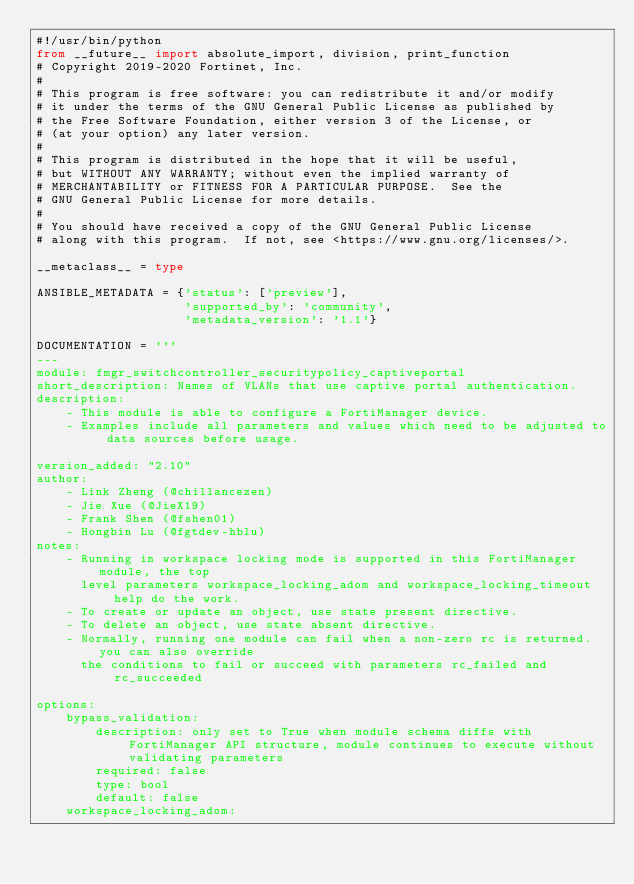Convert code to text. <code><loc_0><loc_0><loc_500><loc_500><_Python_>#!/usr/bin/python
from __future__ import absolute_import, division, print_function
# Copyright 2019-2020 Fortinet, Inc.
#
# This program is free software: you can redistribute it and/or modify
# it under the terms of the GNU General Public License as published by
# the Free Software Foundation, either version 3 of the License, or
# (at your option) any later version.
#
# This program is distributed in the hope that it will be useful,
# but WITHOUT ANY WARRANTY; without even the implied warranty of
# MERCHANTABILITY or FITNESS FOR A PARTICULAR PURPOSE.  See the
# GNU General Public License for more details.
#
# You should have received a copy of the GNU General Public License
# along with this program.  If not, see <https://www.gnu.org/licenses/>.

__metaclass__ = type

ANSIBLE_METADATA = {'status': ['preview'],
                    'supported_by': 'community',
                    'metadata_version': '1.1'}

DOCUMENTATION = '''
---
module: fmgr_switchcontroller_securitypolicy_captiveportal
short_description: Names of VLANs that use captive portal authentication.
description:
    - This module is able to configure a FortiManager device.
    - Examples include all parameters and values which need to be adjusted to data sources before usage.

version_added: "2.10"
author:
    - Link Zheng (@chillancezen)
    - Jie Xue (@JieX19)
    - Frank Shen (@fshen01)
    - Hongbin Lu (@fgtdev-hblu)
notes:
    - Running in workspace locking mode is supported in this FortiManager module, the top
      level parameters workspace_locking_adom and workspace_locking_timeout help do the work.
    - To create or update an object, use state present directive.
    - To delete an object, use state absent directive.
    - Normally, running one module can fail when a non-zero rc is returned. you can also override
      the conditions to fail or succeed with parameters rc_failed and rc_succeeded

options:
    bypass_validation:
        description: only set to True when module schema diffs with FortiManager API structure, module continues to execute without validating parameters
        required: false
        type: bool
        default: false
    workspace_locking_adom:</code> 